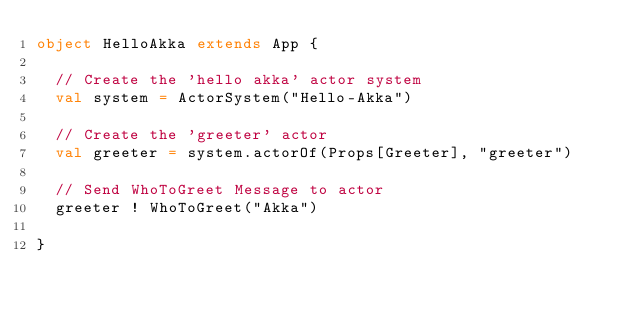Convert code to text. <code><loc_0><loc_0><loc_500><loc_500><_Scala_>object HelloAkka extends App {

  // Create the 'hello akka' actor system
  val system = ActorSystem("Hello-Akka")

  // Create the 'greeter' actor
  val greeter = system.actorOf(Props[Greeter], "greeter")

  // Send WhoToGreet Message to actor
  greeter ! WhoToGreet("Akka")

}
</code> 